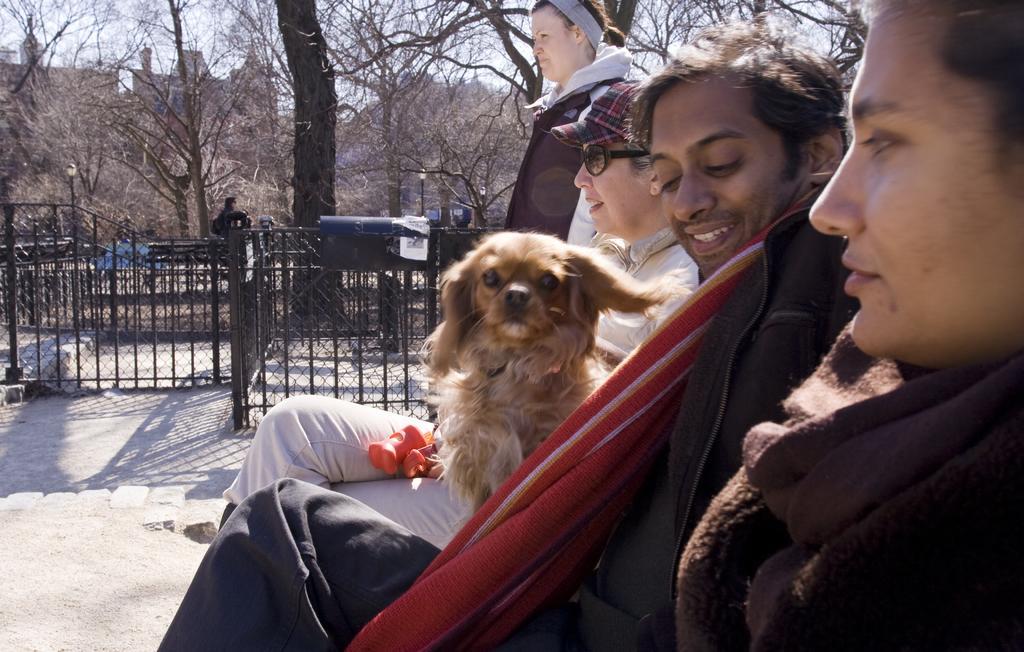How would you summarize this image in a sentence or two? There are three people sitting. the person in the middle is holding small dog. Here is a person standing. This looks like a gate which is black in color. I think there is a person standing. These are the dried trees with branches. And I can see building at the background. These are the streetlights. 